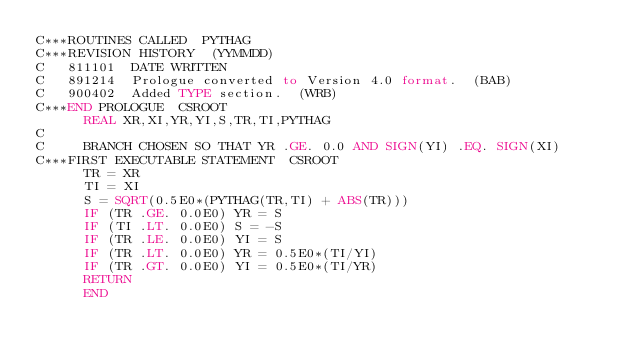<code> <loc_0><loc_0><loc_500><loc_500><_FORTRAN_>C***ROUTINES CALLED  PYTHAG
C***REVISION HISTORY  (YYMMDD)
C   811101  DATE WRITTEN
C   891214  Prologue converted to Version 4.0 format.  (BAB)
C   900402  Added TYPE section.  (WRB)
C***END PROLOGUE  CSROOT
      REAL XR,XI,YR,YI,S,TR,TI,PYTHAG
C
C     BRANCH CHOSEN SO THAT YR .GE. 0.0 AND SIGN(YI) .EQ. SIGN(XI)
C***FIRST EXECUTABLE STATEMENT  CSROOT
      TR = XR
      TI = XI
      S = SQRT(0.5E0*(PYTHAG(TR,TI) + ABS(TR)))
      IF (TR .GE. 0.0E0) YR = S
      IF (TI .LT. 0.0E0) S = -S
      IF (TR .LE. 0.0E0) YI = S
      IF (TR .LT. 0.0E0) YR = 0.5E0*(TI/YI)
      IF (TR .GT. 0.0E0) YI = 0.5E0*(TI/YR)
      RETURN
      END
</code> 